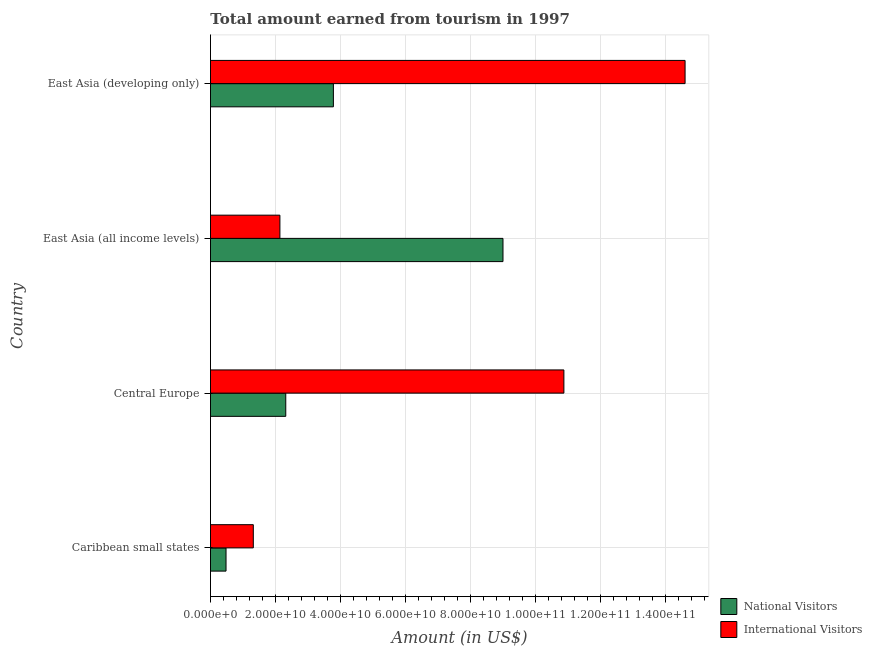How many different coloured bars are there?
Make the answer very short. 2. Are the number of bars per tick equal to the number of legend labels?
Give a very brief answer. Yes. How many bars are there on the 3rd tick from the top?
Your answer should be compact. 2. How many bars are there on the 3rd tick from the bottom?
Provide a short and direct response. 2. What is the label of the 1st group of bars from the top?
Offer a terse response. East Asia (developing only). What is the amount earned from national visitors in East Asia (all income levels)?
Your answer should be compact. 8.99e+1. Across all countries, what is the maximum amount earned from international visitors?
Make the answer very short. 1.46e+11. Across all countries, what is the minimum amount earned from international visitors?
Keep it short and to the point. 1.32e+1. In which country was the amount earned from national visitors maximum?
Make the answer very short. East Asia (all income levels). In which country was the amount earned from national visitors minimum?
Ensure brevity in your answer.  Caribbean small states. What is the total amount earned from international visitors in the graph?
Give a very brief answer. 2.89e+11. What is the difference between the amount earned from national visitors in Caribbean small states and that in East Asia (developing only)?
Offer a terse response. -3.30e+1. What is the difference between the amount earned from national visitors in Caribbean small states and the amount earned from international visitors in East Asia (developing only)?
Provide a succinct answer. -1.41e+11. What is the average amount earned from national visitors per country?
Your response must be concise. 3.89e+1. What is the difference between the amount earned from national visitors and amount earned from international visitors in East Asia (all income levels)?
Provide a short and direct response. 6.86e+1. What is the ratio of the amount earned from national visitors in Caribbean small states to that in East Asia (developing only)?
Ensure brevity in your answer.  0.13. Is the amount earned from national visitors in Caribbean small states less than that in East Asia (all income levels)?
Give a very brief answer. Yes. Is the difference between the amount earned from international visitors in Caribbean small states and East Asia (developing only) greater than the difference between the amount earned from national visitors in Caribbean small states and East Asia (developing only)?
Ensure brevity in your answer.  No. What is the difference between the highest and the second highest amount earned from international visitors?
Your response must be concise. 3.73e+1. What is the difference between the highest and the lowest amount earned from national visitors?
Give a very brief answer. 8.52e+1. What does the 1st bar from the top in East Asia (all income levels) represents?
Ensure brevity in your answer.  International Visitors. What does the 1st bar from the bottom in Caribbean small states represents?
Your answer should be compact. National Visitors. Are all the bars in the graph horizontal?
Ensure brevity in your answer.  Yes. How many countries are there in the graph?
Your response must be concise. 4. What is the difference between two consecutive major ticks on the X-axis?
Ensure brevity in your answer.  2.00e+1. Are the values on the major ticks of X-axis written in scientific E-notation?
Your answer should be very brief. Yes. Does the graph contain any zero values?
Provide a short and direct response. No. Does the graph contain grids?
Make the answer very short. Yes. Where does the legend appear in the graph?
Offer a very short reply. Bottom right. How many legend labels are there?
Provide a succinct answer. 2. How are the legend labels stacked?
Your response must be concise. Vertical. What is the title of the graph?
Offer a terse response. Total amount earned from tourism in 1997. Does "By country of origin" appear as one of the legend labels in the graph?
Offer a very short reply. No. What is the label or title of the X-axis?
Provide a succinct answer. Amount (in US$). What is the Amount (in US$) in National Visitors in Caribbean small states?
Offer a terse response. 4.78e+09. What is the Amount (in US$) in International Visitors in Caribbean small states?
Your answer should be very brief. 1.32e+1. What is the Amount (in US$) in National Visitors in Central Europe?
Offer a very short reply. 2.32e+1. What is the Amount (in US$) of International Visitors in Central Europe?
Ensure brevity in your answer.  1.09e+11. What is the Amount (in US$) in National Visitors in East Asia (all income levels)?
Keep it short and to the point. 8.99e+1. What is the Amount (in US$) of International Visitors in East Asia (all income levels)?
Provide a short and direct response. 2.13e+1. What is the Amount (in US$) in National Visitors in East Asia (developing only)?
Keep it short and to the point. 3.78e+1. What is the Amount (in US$) of International Visitors in East Asia (developing only)?
Your answer should be very brief. 1.46e+11. Across all countries, what is the maximum Amount (in US$) in National Visitors?
Make the answer very short. 8.99e+1. Across all countries, what is the maximum Amount (in US$) of International Visitors?
Provide a short and direct response. 1.46e+11. Across all countries, what is the minimum Amount (in US$) in National Visitors?
Ensure brevity in your answer.  4.78e+09. Across all countries, what is the minimum Amount (in US$) of International Visitors?
Provide a succinct answer. 1.32e+1. What is the total Amount (in US$) in National Visitors in the graph?
Ensure brevity in your answer.  1.56e+11. What is the total Amount (in US$) in International Visitors in the graph?
Ensure brevity in your answer.  2.89e+11. What is the difference between the Amount (in US$) of National Visitors in Caribbean small states and that in Central Europe?
Keep it short and to the point. -1.84e+1. What is the difference between the Amount (in US$) of International Visitors in Caribbean small states and that in Central Europe?
Your answer should be compact. -9.55e+1. What is the difference between the Amount (in US$) of National Visitors in Caribbean small states and that in East Asia (all income levels)?
Give a very brief answer. -8.52e+1. What is the difference between the Amount (in US$) of International Visitors in Caribbean small states and that in East Asia (all income levels)?
Make the answer very short. -8.18e+09. What is the difference between the Amount (in US$) of National Visitors in Caribbean small states and that in East Asia (developing only)?
Your response must be concise. -3.30e+1. What is the difference between the Amount (in US$) in International Visitors in Caribbean small states and that in East Asia (developing only)?
Provide a short and direct response. -1.33e+11. What is the difference between the Amount (in US$) of National Visitors in Central Europe and that in East Asia (all income levels)?
Make the answer very short. -6.68e+1. What is the difference between the Amount (in US$) of International Visitors in Central Europe and that in East Asia (all income levels)?
Offer a terse response. 8.73e+1. What is the difference between the Amount (in US$) of National Visitors in Central Europe and that in East Asia (developing only)?
Your response must be concise. -1.46e+1. What is the difference between the Amount (in US$) of International Visitors in Central Europe and that in East Asia (developing only)?
Make the answer very short. -3.73e+1. What is the difference between the Amount (in US$) in National Visitors in East Asia (all income levels) and that in East Asia (developing only)?
Your response must be concise. 5.21e+1. What is the difference between the Amount (in US$) of International Visitors in East Asia (all income levels) and that in East Asia (developing only)?
Give a very brief answer. -1.25e+11. What is the difference between the Amount (in US$) in National Visitors in Caribbean small states and the Amount (in US$) in International Visitors in Central Europe?
Make the answer very short. -1.04e+11. What is the difference between the Amount (in US$) of National Visitors in Caribbean small states and the Amount (in US$) of International Visitors in East Asia (all income levels)?
Your response must be concise. -1.66e+1. What is the difference between the Amount (in US$) of National Visitors in Caribbean small states and the Amount (in US$) of International Visitors in East Asia (developing only)?
Offer a terse response. -1.41e+11. What is the difference between the Amount (in US$) of National Visitors in Central Europe and the Amount (in US$) of International Visitors in East Asia (all income levels)?
Provide a short and direct response. 1.80e+09. What is the difference between the Amount (in US$) in National Visitors in Central Europe and the Amount (in US$) in International Visitors in East Asia (developing only)?
Your answer should be very brief. -1.23e+11. What is the difference between the Amount (in US$) of National Visitors in East Asia (all income levels) and the Amount (in US$) of International Visitors in East Asia (developing only)?
Your response must be concise. -5.60e+1. What is the average Amount (in US$) in National Visitors per country?
Make the answer very short. 3.89e+1. What is the average Amount (in US$) in International Visitors per country?
Your answer should be compact. 7.23e+1. What is the difference between the Amount (in US$) in National Visitors and Amount (in US$) in International Visitors in Caribbean small states?
Ensure brevity in your answer.  -8.39e+09. What is the difference between the Amount (in US$) of National Visitors and Amount (in US$) of International Visitors in Central Europe?
Your response must be concise. -8.55e+1. What is the difference between the Amount (in US$) of National Visitors and Amount (in US$) of International Visitors in East Asia (all income levels)?
Your answer should be compact. 6.86e+1. What is the difference between the Amount (in US$) in National Visitors and Amount (in US$) in International Visitors in East Asia (developing only)?
Provide a short and direct response. -1.08e+11. What is the ratio of the Amount (in US$) of National Visitors in Caribbean small states to that in Central Europe?
Offer a terse response. 0.21. What is the ratio of the Amount (in US$) in International Visitors in Caribbean small states to that in Central Europe?
Make the answer very short. 0.12. What is the ratio of the Amount (in US$) of National Visitors in Caribbean small states to that in East Asia (all income levels)?
Your answer should be very brief. 0.05. What is the ratio of the Amount (in US$) of International Visitors in Caribbean small states to that in East Asia (all income levels)?
Give a very brief answer. 0.62. What is the ratio of the Amount (in US$) of National Visitors in Caribbean small states to that in East Asia (developing only)?
Make the answer very short. 0.13. What is the ratio of the Amount (in US$) in International Visitors in Caribbean small states to that in East Asia (developing only)?
Provide a succinct answer. 0.09. What is the ratio of the Amount (in US$) of National Visitors in Central Europe to that in East Asia (all income levels)?
Provide a succinct answer. 0.26. What is the ratio of the Amount (in US$) in International Visitors in Central Europe to that in East Asia (all income levels)?
Give a very brief answer. 5.09. What is the ratio of the Amount (in US$) in National Visitors in Central Europe to that in East Asia (developing only)?
Your answer should be compact. 0.61. What is the ratio of the Amount (in US$) of International Visitors in Central Europe to that in East Asia (developing only)?
Make the answer very short. 0.74. What is the ratio of the Amount (in US$) of National Visitors in East Asia (all income levels) to that in East Asia (developing only)?
Your response must be concise. 2.38. What is the ratio of the Amount (in US$) in International Visitors in East Asia (all income levels) to that in East Asia (developing only)?
Make the answer very short. 0.15. What is the difference between the highest and the second highest Amount (in US$) in National Visitors?
Your answer should be very brief. 5.21e+1. What is the difference between the highest and the second highest Amount (in US$) of International Visitors?
Your answer should be compact. 3.73e+1. What is the difference between the highest and the lowest Amount (in US$) of National Visitors?
Your answer should be very brief. 8.52e+1. What is the difference between the highest and the lowest Amount (in US$) of International Visitors?
Provide a succinct answer. 1.33e+11. 